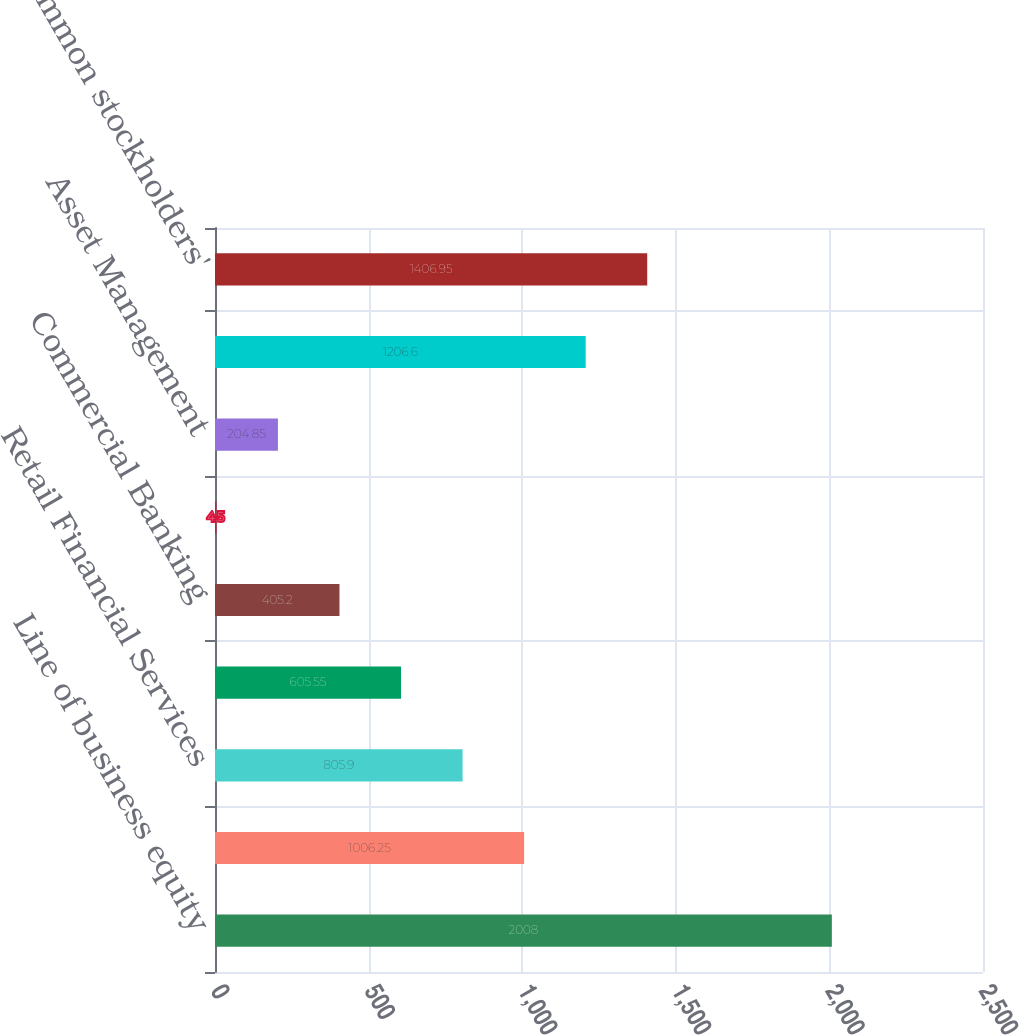<chart> <loc_0><loc_0><loc_500><loc_500><bar_chart><fcel>Line of business equity<fcel>Investment Bank<fcel>Retail Financial Services<fcel>Card Services<fcel>Commercial Banking<fcel>Treasury & Securities Services<fcel>Asset Management<fcel>Corporate/Private Equity<fcel>Total common stockholders'<nl><fcel>2008<fcel>1006.25<fcel>805.9<fcel>605.55<fcel>405.2<fcel>4.5<fcel>204.85<fcel>1206.6<fcel>1406.95<nl></chart> 